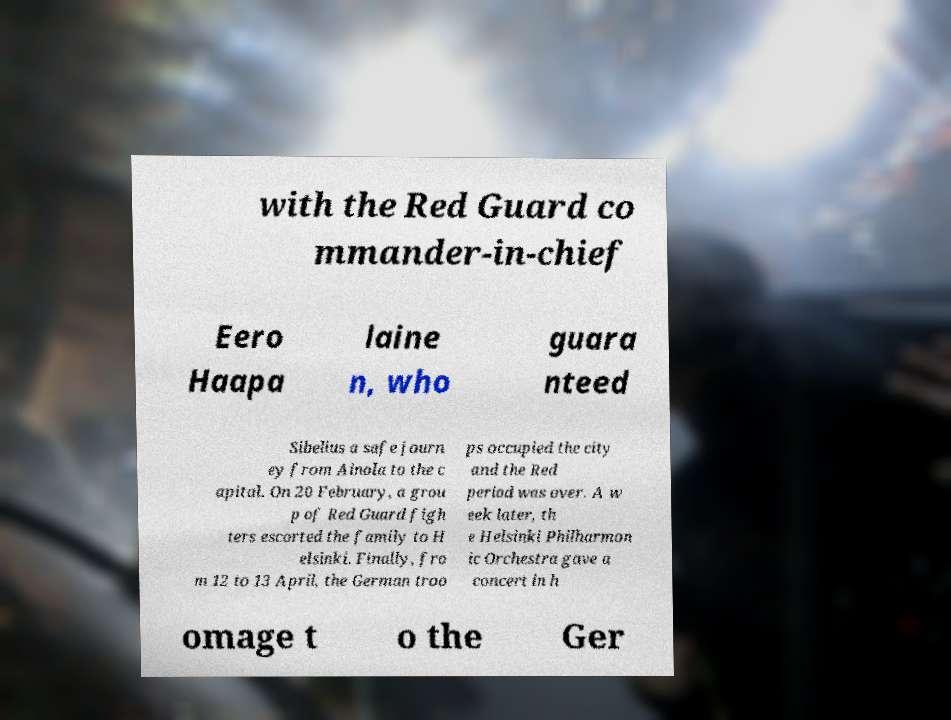Please read and relay the text visible in this image. What does it say? with the Red Guard co mmander-in-chief Eero Haapa laine n, who guara nteed Sibelius a safe journ ey from Ainola to the c apital. On 20 February, a grou p of Red Guard figh ters escorted the family to H elsinki. Finally, fro m 12 to 13 April, the German troo ps occupied the city and the Red period was over. A w eek later, th e Helsinki Philharmon ic Orchestra gave a concert in h omage t o the Ger 